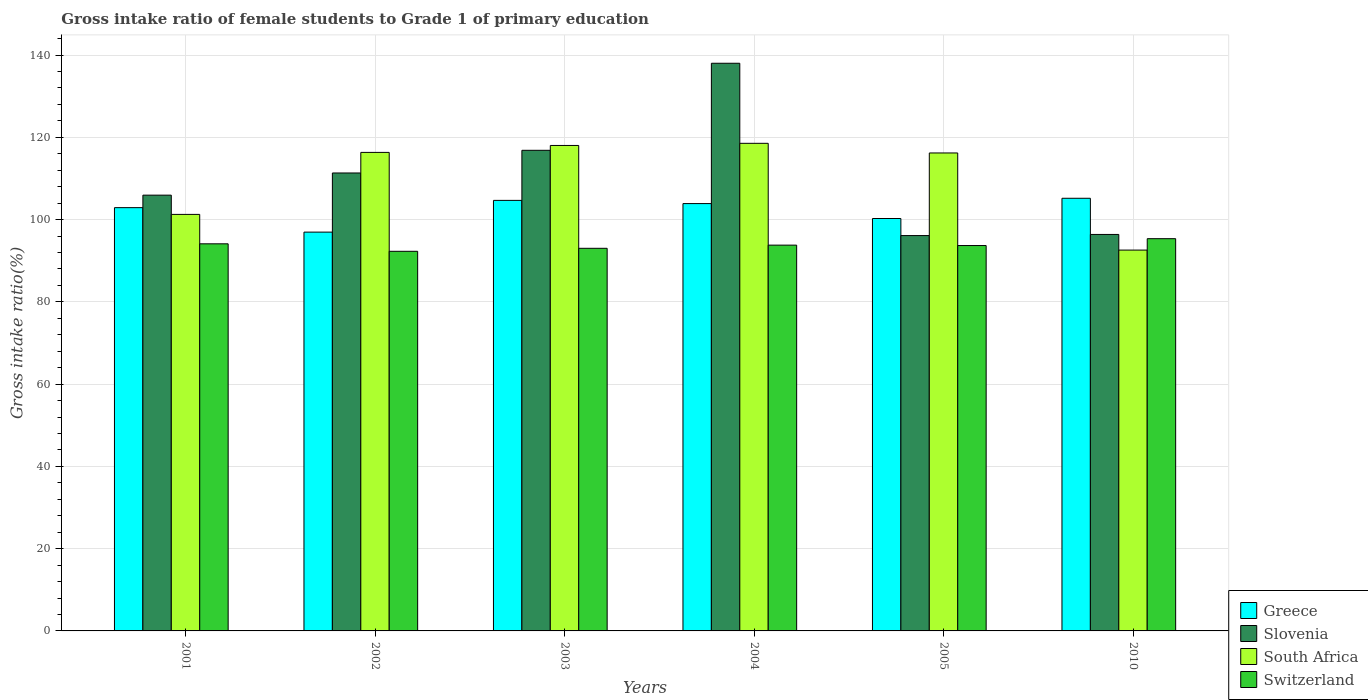Are the number of bars per tick equal to the number of legend labels?
Provide a succinct answer. Yes. How many bars are there on the 1st tick from the left?
Keep it short and to the point. 4. How many bars are there on the 1st tick from the right?
Offer a very short reply. 4. What is the label of the 6th group of bars from the left?
Your answer should be compact. 2010. What is the gross intake ratio in Greece in 2002?
Your answer should be very brief. 96.95. Across all years, what is the maximum gross intake ratio in Greece?
Your answer should be very brief. 105.18. Across all years, what is the minimum gross intake ratio in Slovenia?
Your answer should be compact. 96.11. In which year was the gross intake ratio in Switzerland minimum?
Your answer should be very brief. 2002. What is the total gross intake ratio in South Africa in the graph?
Your answer should be very brief. 662.92. What is the difference between the gross intake ratio in Switzerland in 2004 and that in 2010?
Keep it short and to the point. -1.57. What is the difference between the gross intake ratio in South Africa in 2003 and the gross intake ratio in Switzerland in 2004?
Provide a short and direct response. 24.23. What is the average gross intake ratio in Greece per year?
Ensure brevity in your answer.  102.31. In the year 2001, what is the difference between the gross intake ratio in South Africa and gross intake ratio in Switzerland?
Ensure brevity in your answer.  7.15. What is the ratio of the gross intake ratio in Slovenia in 2001 to that in 2003?
Your response must be concise. 0.91. Is the difference between the gross intake ratio in South Africa in 2004 and 2010 greater than the difference between the gross intake ratio in Switzerland in 2004 and 2010?
Provide a short and direct response. Yes. What is the difference between the highest and the second highest gross intake ratio in Slovenia?
Your answer should be very brief. 21.16. What is the difference between the highest and the lowest gross intake ratio in Greece?
Offer a terse response. 8.23. In how many years, is the gross intake ratio in Switzerland greater than the average gross intake ratio in Switzerland taken over all years?
Your response must be concise. 3. Is it the case that in every year, the sum of the gross intake ratio in South Africa and gross intake ratio in Greece is greater than the sum of gross intake ratio in Slovenia and gross intake ratio in Switzerland?
Your response must be concise. Yes. What does the 2nd bar from the left in 2001 represents?
Your response must be concise. Slovenia. What does the 2nd bar from the right in 2010 represents?
Your answer should be very brief. South Africa. Is it the case that in every year, the sum of the gross intake ratio in Switzerland and gross intake ratio in Slovenia is greater than the gross intake ratio in Greece?
Ensure brevity in your answer.  Yes. How many years are there in the graph?
Your answer should be compact. 6. What is the difference between two consecutive major ticks on the Y-axis?
Provide a short and direct response. 20. Are the values on the major ticks of Y-axis written in scientific E-notation?
Make the answer very short. No. Does the graph contain any zero values?
Provide a succinct answer. No. How are the legend labels stacked?
Provide a succinct answer. Vertical. What is the title of the graph?
Ensure brevity in your answer.  Gross intake ratio of female students to Grade 1 of primary education. What is the label or title of the X-axis?
Ensure brevity in your answer.  Years. What is the label or title of the Y-axis?
Offer a terse response. Gross intake ratio(%). What is the Gross intake ratio(%) of Greece in 2001?
Your answer should be very brief. 102.9. What is the Gross intake ratio(%) in Slovenia in 2001?
Keep it short and to the point. 105.94. What is the Gross intake ratio(%) of South Africa in 2001?
Provide a short and direct response. 101.26. What is the Gross intake ratio(%) of Switzerland in 2001?
Provide a short and direct response. 94.11. What is the Gross intake ratio(%) in Greece in 2002?
Provide a short and direct response. 96.95. What is the Gross intake ratio(%) of Slovenia in 2002?
Your answer should be very brief. 111.33. What is the Gross intake ratio(%) in South Africa in 2002?
Keep it short and to the point. 116.33. What is the Gross intake ratio(%) in Switzerland in 2002?
Keep it short and to the point. 92.29. What is the Gross intake ratio(%) of Greece in 2003?
Offer a terse response. 104.67. What is the Gross intake ratio(%) of Slovenia in 2003?
Your answer should be very brief. 116.84. What is the Gross intake ratio(%) of South Africa in 2003?
Give a very brief answer. 118.02. What is the Gross intake ratio(%) in Switzerland in 2003?
Your answer should be very brief. 93.01. What is the Gross intake ratio(%) of Greece in 2004?
Your answer should be very brief. 103.89. What is the Gross intake ratio(%) of Slovenia in 2004?
Give a very brief answer. 138. What is the Gross intake ratio(%) of South Africa in 2004?
Your response must be concise. 118.54. What is the Gross intake ratio(%) in Switzerland in 2004?
Offer a very short reply. 93.79. What is the Gross intake ratio(%) of Greece in 2005?
Your answer should be very brief. 100.26. What is the Gross intake ratio(%) of Slovenia in 2005?
Your response must be concise. 96.11. What is the Gross intake ratio(%) of South Africa in 2005?
Your answer should be compact. 116.2. What is the Gross intake ratio(%) in Switzerland in 2005?
Offer a very short reply. 93.69. What is the Gross intake ratio(%) of Greece in 2010?
Keep it short and to the point. 105.18. What is the Gross intake ratio(%) of Slovenia in 2010?
Offer a very short reply. 96.39. What is the Gross intake ratio(%) in South Africa in 2010?
Your answer should be very brief. 92.58. What is the Gross intake ratio(%) in Switzerland in 2010?
Your answer should be very brief. 95.36. Across all years, what is the maximum Gross intake ratio(%) in Greece?
Give a very brief answer. 105.18. Across all years, what is the maximum Gross intake ratio(%) of Slovenia?
Give a very brief answer. 138. Across all years, what is the maximum Gross intake ratio(%) in South Africa?
Give a very brief answer. 118.54. Across all years, what is the maximum Gross intake ratio(%) in Switzerland?
Your answer should be compact. 95.36. Across all years, what is the minimum Gross intake ratio(%) in Greece?
Make the answer very short. 96.95. Across all years, what is the minimum Gross intake ratio(%) of Slovenia?
Provide a short and direct response. 96.11. Across all years, what is the minimum Gross intake ratio(%) of South Africa?
Your response must be concise. 92.58. Across all years, what is the minimum Gross intake ratio(%) of Switzerland?
Keep it short and to the point. 92.29. What is the total Gross intake ratio(%) of Greece in the graph?
Make the answer very short. 613.84. What is the total Gross intake ratio(%) of Slovenia in the graph?
Make the answer very short. 664.6. What is the total Gross intake ratio(%) in South Africa in the graph?
Your answer should be very brief. 662.92. What is the total Gross intake ratio(%) of Switzerland in the graph?
Give a very brief answer. 562.24. What is the difference between the Gross intake ratio(%) of Greece in 2001 and that in 2002?
Offer a very short reply. 5.95. What is the difference between the Gross intake ratio(%) in Slovenia in 2001 and that in 2002?
Offer a terse response. -5.39. What is the difference between the Gross intake ratio(%) of South Africa in 2001 and that in 2002?
Your answer should be compact. -15.07. What is the difference between the Gross intake ratio(%) in Switzerland in 2001 and that in 2002?
Your response must be concise. 1.82. What is the difference between the Gross intake ratio(%) in Greece in 2001 and that in 2003?
Give a very brief answer. -1.77. What is the difference between the Gross intake ratio(%) in Slovenia in 2001 and that in 2003?
Ensure brevity in your answer.  -10.9. What is the difference between the Gross intake ratio(%) of South Africa in 2001 and that in 2003?
Make the answer very short. -16.76. What is the difference between the Gross intake ratio(%) in Switzerland in 2001 and that in 2003?
Offer a terse response. 1.09. What is the difference between the Gross intake ratio(%) of Greece in 2001 and that in 2004?
Provide a short and direct response. -0.99. What is the difference between the Gross intake ratio(%) in Slovenia in 2001 and that in 2004?
Offer a very short reply. -32.06. What is the difference between the Gross intake ratio(%) of South Africa in 2001 and that in 2004?
Provide a succinct answer. -17.28. What is the difference between the Gross intake ratio(%) in Switzerland in 2001 and that in 2004?
Provide a short and direct response. 0.32. What is the difference between the Gross intake ratio(%) of Greece in 2001 and that in 2005?
Keep it short and to the point. 2.64. What is the difference between the Gross intake ratio(%) in Slovenia in 2001 and that in 2005?
Offer a terse response. 9.83. What is the difference between the Gross intake ratio(%) in South Africa in 2001 and that in 2005?
Make the answer very short. -14.94. What is the difference between the Gross intake ratio(%) of Switzerland in 2001 and that in 2005?
Provide a short and direct response. 0.42. What is the difference between the Gross intake ratio(%) of Greece in 2001 and that in 2010?
Ensure brevity in your answer.  -2.28. What is the difference between the Gross intake ratio(%) of Slovenia in 2001 and that in 2010?
Offer a very short reply. 9.55. What is the difference between the Gross intake ratio(%) in South Africa in 2001 and that in 2010?
Provide a short and direct response. 8.68. What is the difference between the Gross intake ratio(%) in Switzerland in 2001 and that in 2010?
Provide a succinct answer. -1.25. What is the difference between the Gross intake ratio(%) of Greece in 2002 and that in 2003?
Offer a very short reply. -7.72. What is the difference between the Gross intake ratio(%) of Slovenia in 2002 and that in 2003?
Your answer should be very brief. -5.51. What is the difference between the Gross intake ratio(%) of South Africa in 2002 and that in 2003?
Provide a succinct answer. -1.69. What is the difference between the Gross intake ratio(%) in Switzerland in 2002 and that in 2003?
Keep it short and to the point. -0.73. What is the difference between the Gross intake ratio(%) in Greece in 2002 and that in 2004?
Keep it short and to the point. -6.94. What is the difference between the Gross intake ratio(%) of Slovenia in 2002 and that in 2004?
Provide a short and direct response. -26.67. What is the difference between the Gross intake ratio(%) of South Africa in 2002 and that in 2004?
Your answer should be compact. -2.21. What is the difference between the Gross intake ratio(%) in Switzerland in 2002 and that in 2004?
Keep it short and to the point. -1.5. What is the difference between the Gross intake ratio(%) of Greece in 2002 and that in 2005?
Offer a terse response. -3.31. What is the difference between the Gross intake ratio(%) of Slovenia in 2002 and that in 2005?
Provide a short and direct response. 15.22. What is the difference between the Gross intake ratio(%) in South Africa in 2002 and that in 2005?
Ensure brevity in your answer.  0.14. What is the difference between the Gross intake ratio(%) in Switzerland in 2002 and that in 2005?
Make the answer very short. -1.4. What is the difference between the Gross intake ratio(%) of Greece in 2002 and that in 2010?
Give a very brief answer. -8.23. What is the difference between the Gross intake ratio(%) of Slovenia in 2002 and that in 2010?
Keep it short and to the point. 14.94. What is the difference between the Gross intake ratio(%) of South Africa in 2002 and that in 2010?
Your response must be concise. 23.75. What is the difference between the Gross intake ratio(%) in Switzerland in 2002 and that in 2010?
Provide a succinct answer. -3.07. What is the difference between the Gross intake ratio(%) of Greece in 2003 and that in 2004?
Provide a short and direct response. 0.78. What is the difference between the Gross intake ratio(%) in Slovenia in 2003 and that in 2004?
Provide a succinct answer. -21.16. What is the difference between the Gross intake ratio(%) of South Africa in 2003 and that in 2004?
Your answer should be compact. -0.52. What is the difference between the Gross intake ratio(%) of Switzerland in 2003 and that in 2004?
Make the answer very short. -0.77. What is the difference between the Gross intake ratio(%) in Greece in 2003 and that in 2005?
Give a very brief answer. 4.41. What is the difference between the Gross intake ratio(%) in Slovenia in 2003 and that in 2005?
Give a very brief answer. 20.73. What is the difference between the Gross intake ratio(%) in South Africa in 2003 and that in 2005?
Your answer should be compact. 1.82. What is the difference between the Gross intake ratio(%) of Switzerland in 2003 and that in 2005?
Keep it short and to the point. -0.67. What is the difference between the Gross intake ratio(%) of Greece in 2003 and that in 2010?
Provide a succinct answer. -0.51. What is the difference between the Gross intake ratio(%) of Slovenia in 2003 and that in 2010?
Your answer should be very brief. 20.45. What is the difference between the Gross intake ratio(%) in South Africa in 2003 and that in 2010?
Keep it short and to the point. 25.44. What is the difference between the Gross intake ratio(%) in Switzerland in 2003 and that in 2010?
Your response must be concise. -2.34. What is the difference between the Gross intake ratio(%) of Greece in 2004 and that in 2005?
Your response must be concise. 3.62. What is the difference between the Gross intake ratio(%) in Slovenia in 2004 and that in 2005?
Provide a short and direct response. 41.89. What is the difference between the Gross intake ratio(%) in South Africa in 2004 and that in 2005?
Offer a terse response. 2.34. What is the difference between the Gross intake ratio(%) of Switzerland in 2004 and that in 2005?
Offer a terse response. 0.1. What is the difference between the Gross intake ratio(%) in Greece in 2004 and that in 2010?
Ensure brevity in your answer.  -1.29. What is the difference between the Gross intake ratio(%) in Slovenia in 2004 and that in 2010?
Keep it short and to the point. 41.61. What is the difference between the Gross intake ratio(%) in South Africa in 2004 and that in 2010?
Provide a succinct answer. 25.96. What is the difference between the Gross intake ratio(%) of Switzerland in 2004 and that in 2010?
Keep it short and to the point. -1.57. What is the difference between the Gross intake ratio(%) of Greece in 2005 and that in 2010?
Your answer should be compact. -4.92. What is the difference between the Gross intake ratio(%) of Slovenia in 2005 and that in 2010?
Your answer should be very brief. -0.28. What is the difference between the Gross intake ratio(%) of South Africa in 2005 and that in 2010?
Provide a succinct answer. 23.61. What is the difference between the Gross intake ratio(%) in Switzerland in 2005 and that in 2010?
Provide a short and direct response. -1.67. What is the difference between the Gross intake ratio(%) of Greece in 2001 and the Gross intake ratio(%) of Slovenia in 2002?
Provide a short and direct response. -8.43. What is the difference between the Gross intake ratio(%) in Greece in 2001 and the Gross intake ratio(%) in South Africa in 2002?
Offer a very short reply. -13.43. What is the difference between the Gross intake ratio(%) of Greece in 2001 and the Gross intake ratio(%) of Switzerland in 2002?
Give a very brief answer. 10.61. What is the difference between the Gross intake ratio(%) of Slovenia in 2001 and the Gross intake ratio(%) of South Africa in 2002?
Give a very brief answer. -10.39. What is the difference between the Gross intake ratio(%) of Slovenia in 2001 and the Gross intake ratio(%) of Switzerland in 2002?
Your answer should be compact. 13.65. What is the difference between the Gross intake ratio(%) in South Africa in 2001 and the Gross intake ratio(%) in Switzerland in 2002?
Give a very brief answer. 8.97. What is the difference between the Gross intake ratio(%) of Greece in 2001 and the Gross intake ratio(%) of Slovenia in 2003?
Give a very brief answer. -13.94. What is the difference between the Gross intake ratio(%) of Greece in 2001 and the Gross intake ratio(%) of South Africa in 2003?
Your answer should be very brief. -15.12. What is the difference between the Gross intake ratio(%) of Greece in 2001 and the Gross intake ratio(%) of Switzerland in 2003?
Provide a short and direct response. 9.88. What is the difference between the Gross intake ratio(%) in Slovenia in 2001 and the Gross intake ratio(%) in South Africa in 2003?
Offer a very short reply. -12.08. What is the difference between the Gross intake ratio(%) in Slovenia in 2001 and the Gross intake ratio(%) in Switzerland in 2003?
Ensure brevity in your answer.  12.92. What is the difference between the Gross intake ratio(%) of South Africa in 2001 and the Gross intake ratio(%) of Switzerland in 2003?
Provide a short and direct response. 8.24. What is the difference between the Gross intake ratio(%) of Greece in 2001 and the Gross intake ratio(%) of Slovenia in 2004?
Give a very brief answer. -35.1. What is the difference between the Gross intake ratio(%) of Greece in 2001 and the Gross intake ratio(%) of South Africa in 2004?
Keep it short and to the point. -15.64. What is the difference between the Gross intake ratio(%) in Greece in 2001 and the Gross intake ratio(%) in Switzerland in 2004?
Offer a very short reply. 9.11. What is the difference between the Gross intake ratio(%) in Slovenia in 2001 and the Gross intake ratio(%) in South Africa in 2004?
Make the answer very short. -12.6. What is the difference between the Gross intake ratio(%) in Slovenia in 2001 and the Gross intake ratio(%) in Switzerland in 2004?
Offer a very short reply. 12.15. What is the difference between the Gross intake ratio(%) in South Africa in 2001 and the Gross intake ratio(%) in Switzerland in 2004?
Offer a very short reply. 7.47. What is the difference between the Gross intake ratio(%) of Greece in 2001 and the Gross intake ratio(%) of Slovenia in 2005?
Ensure brevity in your answer.  6.79. What is the difference between the Gross intake ratio(%) of Greece in 2001 and the Gross intake ratio(%) of South Africa in 2005?
Give a very brief answer. -13.3. What is the difference between the Gross intake ratio(%) of Greece in 2001 and the Gross intake ratio(%) of Switzerland in 2005?
Offer a very short reply. 9.21. What is the difference between the Gross intake ratio(%) in Slovenia in 2001 and the Gross intake ratio(%) in South Africa in 2005?
Your response must be concise. -10.26. What is the difference between the Gross intake ratio(%) of Slovenia in 2001 and the Gross intake ratio(%) of Switzerland in 2005?
Ensure brevity in your answer.  12.25. What is the difference between the Gross intake ratio(%) of South Africa in 2001 and the Gross intake ratio(%) of Switzerland in 2005?
Provide a succinct answer. 7.57. What is the difference between the Gross intake ratio(%) of Greece in 2001 and the Gross intake ratio(%) of Slovenia in 2010?
Offer a terse response. 6.51. What is the difference between the Gross intake ratio(%) of Greece in 2001 and the Gross intake ratio(%) of South Africa in 2010?
Give a very brief answer. 10.32. What is the difference between the Gross intake ratio(%) of Greece in 2001 and the Gross intake ratio(%) of Switzerland in 2010?
Provide a succinct answer. 7.54. What is the difference between the Gross intake ratio(%) of Slovenia in 2001 and the Gross intake ratio(%) of South Africa in 2010?
Provide a short and direct response. 13.36. What is the difference between the Gross intake ratio(%) in Slovenia in 2001 and the Gross intake ratio(%) in Switzerland in 2010?
Keep it short and to the point. 10.58. What is the difference between the Gross intake ratio(%) in South Africa in 2001 and the Gross intake ratio(%) in Switzerland in 2010?
Offer a very short reply. 5.9. What is the difference between the Gross intake ratio(%) of Greece in 2002 and the Gross intake ratio(%) of Slovenia in 2003?
Offer a very short reply. -19.89. What is the difference between the Gross intake ratio(%) in Greece in 2002 and the Gross intake ratio(%) in South Africa in 2003?
Give a very brief answer. -21.07. What is the difference between the Gross intake ratio(%) in Greece in 2002 and the Gross intake ratio(%) in Switzerland in 2003?
Keep it short and to the point. 3.94. What is the difference between the Gross intake ratio(%) in Slovenia in 2002 and the Gross intake ratio(%) in South Africa in 2003?
Offer a terse response. -6.69. What is the difference between the Gross intake ratio(%) in Slovenia in 2002 and the Gross intake ratio(%) in Switzerland in 2003?
Provide a short and direct response. 18.31. What is the difference between the Gross intake ratio(%) of South Africa in 2002 and the Gross intake ratio(%) of Switzerland in 2003?
Your answer should be very brief. 23.32. What is the difference between the Gross intake ratio(%) of Greece in 2002 and the Gross intake ratio(%) of Slovenia in 2004?
Offer a terse response. -41.05. What is the difference between the Gross intake ratio(%) of Greece in 2002 and the Gross intake ratio(%) of South Africa in 2004?
Provide a succinct answer. -21.59. What is the difference between the Gross intake ratio(%) of Greece in 2002 and the Gross intake ratio(%) of Switzerland in 2004?
Give a very brief answer. 3.16. What is the difference between the Gross intake ratio(%) of Slovenia in 2002 and the Gross intake ratio(%) of South Africa in 2004?
Your answer should be very brief. -7.21. What is the difference between the Gross intake ratio(%) in Slovenia in 2002 and the Gross intake ratio(%) in Switzerland in 2004?
Your answer should be compact. 17.54. What is the difference between the Gross intake ratio(%) of South Africa in 2002 and the Gross intake ratio(%) of Switzerland in 2004?
Offer a terse response. 22.54. What is the difference between the Gross intake ratio(%) in Greece in 2002 and the Gross intake ratio(%) in Slovenia in 2005?
Provide a succinct answer. 0.84. What is the difference between the Gross intake ratio(%) of Greece in 2002 and the Gross intake ratio(%) of South Africa in 2005?
Your response must be concise. -19.25. What is the difference between the Gross intake ratio(%) in Greece in 2002 and the Gross intake ratio(%) in Switzerland in 2005?
Offer a very short reply. 3.26. What is the difference between the Gross intake ratio(%) in Slovenia in 2002 and the Gross intake ratio(%) in South Africa in 2005?
Ensure brevity in your answer.  -4.87. What is the difference between the Gross intake ratio(%) in Slovenia in 2002 and the Gross intake ratio(%) in Switzerland in 2005?
Ensure brevity in your answer.  17.64. What is the difference between the Gross intake ratio(%) of South Africa in 2002 and the Gross intake ratio(%) of Switzerland in 2005?
Offer a terse response. 22.64. What is the difference between the Gross intake ratio(%) of Greece in 2002 and the Gross intake ratio(%) of Slovenia in 2010?
Make the answer very short. 0.56. What is the difference between the Gross intake ratio(%) in Greece in 2002 and the Gross intake ratio(%) in South Africa in 2010?
Provide a succinct answer. 4.37. What is the difference between the Gross intake ratio(%) in Greece in 2002 and the Gross intake ratio(%) in Switzerland in 2010?
Provide a short and direct response. 1.59. What is the difference between the Gross intake ratio(%) of Slovenia in 2002 and the Gross intake ratio(%) of South Africa in 2010?
Your answer should be very brief. 18.75. What is the difference between the Gross intake ratio(%) in Slovenia in 2002 and the Gross intake ratio(%) in Switzerland in 2010?
Offer a terse response. 15.97. What is the difference between the Gross intake ratio(%) of South Africa in 2002 and the Gross intake ratio(%) of Switzerland in 2010?
Provide a short and direct response. 20.98. What is the difference between the Gross intake ratio(%) of Greece in 2003 and the Gross intake ratio(%) of Slovenia in 2004?
Provide a short and direct response. -33.33. What is the difference between the Gross intake ratio(%) of Greece in 2003 and the Gross intake ratio(%) of South Africa in 2004?
Provide a succinct answer. -13.87. What is the difference between the Gross intake ratio(%) of Greece in 2003 and the Gross intake ratio(%) of Switzerland in 2004?
Ensure brevity in your answer.  10.88. What is the difference between the Gross intake ratio(%) in Slovenia in 2003 and the Gross intake ratio(%) in South Africa in 2004?
Ensure brevity in your answer.  -1.7. What is the difference between the Gross intake ratio(%) in Slovenia in 2003 and the Gross intake ratio(%) in Switzerland in 2004?
Make the answer very short. 23.05. What is the difference between the Gross intake ratio(%) in South Africa in 2003 and the Gross intake ratio(%) in Switzerland in 2004?
Make the answer very short. 24.23. What is the difference between the Gross intake ratio(%) of Greece in 2003 and the Gross intake ratio(%) of Slovenia in 2005?
Your answer should be very brief. 8.56. What is the difference between the Gross intake ratio(%) in Greece in 2003 and the Gross intake ratio(%) in South Africa in 2005?
Keep it short and to the point. -11.53. What is the difference between the Gross intake ratio(%) in Greece in 2003 and the Gross intake ratio(%) in Switzerland in 2005?
Offer a terse response. 10.98. What is the difference between the Gross intake ratio(%) in Slovenia in 2003 and the Gross intake ratio(%) in South Africa in 2005?
Provide a short and direct response. 0.64. What is the difference between the Gross intake ratio(%) of Slovenia in 2003 and the Gross intake ratio(%) of Switzerland in 2005?
Keep it short and to the point. 23.15. What is the difference between the Gross intake ratio(%) in South Africa in 2003 and the Gross intake ratio(%) in Switzerland in 2005?
Offer a terse response. 24.33. What is the difference between the Gross intake ratio(%) of Greece in 2003 and the Gross intake ratio(%) of Slovenia in 2010?
Offer a very short reply. 8.28. What is the difference between the Gross intake ratio(%) in Greece in 2003 and the Gross intake ratio(%) in South Africa in 2010?
Offer a very short reply. 12.09. What is the difference between the Gross intake ratio(%) in Greece in 2003 and the Gross intake ratio(%) in Switzerland in 2010?
Keep it short and to the point. 9.31. What is the difference between the Gross intake ratio(%) in Slovenia in 2003 and the Gross intake ratio(%) in South Africa in 2010?
Keep it short and to the point. 24.26. What is the difference between the Gross intake ratio(%) of Slovenia in 2003 and the Gross intake ratio(%) of Switzerland in 2010?
Your answer should be compact. 21.48. What is the difference between the Gross intake ratio(%) of South Africa in 2003 and the Gross intake ratio(%) of Switzerland in 2010?
Ensure brevity in your answer.  22.66. What is the difference between the Gross intake ratio(%) in Greece in 2004 and the Gross intake ratio(%) in Slovenia in 2005?
Keep it short and to the point. 7.78. What is the difference between the Gross intake ratio(%) of Greece in 2004 and the Gross intake ratio(%) of South Africa in 2005?
Make the answer very short. -12.31. What is the difference between the Gross intake ratio(%) of Greece in 2004 and the Gross intake ratio(%) of Switzerland in 2005?
Your answer should be very brief. 10.2. What is the difference between the Gross intake ratio(%) in Slovenia in 2004 and the Gross intake ratio(%) in South Africa in 2005?
Your response must be concise. 21.81. What is the difference between the Gross intake ratio(%) in Slovenia in 2004 and the Gross intake ratio(%) in Switzerland in 2005?
Make the answer very short. 44.31. What is the difference between the Gross intake ratio(%) of South Africa in 2004 and the Gross intake ratio(%) of Switzerland in 2005?
Offer a terse response. 24.85. What is the difference between the Gross intake ratio(%) in Greece in 2004 and the Gross intake ratio(%) in Slovenia in 2010?
Keep it short and to the point. 7.5. What is the difference between the Gross intake ratio(%) of Greece in 2004 and the Gross intake ratio(%) of South Africa in 2010?
Ensure brevity in your answer.  11.3. What is the difference between the Gross intake ratio(%) in Greece in 2004 and the Gross intake ratio(%) in Switzerland in 2010?
Offer a very short reply. 8.53. What is the difference between the Gross intake ratio(%) of Slovenia in 2004 and the Gross intake ratio(%) of South Africa in 2010?
Ensure brevity in your answer.  45.42. What is the difference between the Gross intake ratio(%) of Slovenia in 2004 and the Gross intake ratio(%) of Switzerland in 2010?
Offer a terse response. 42.65. What is the difference between the Gross intake ratio(%) in South Africa in 2004 and the Gross intake ratio(%) in Switzerland in 2010?
Provide a succinct answer. 23.18. What is the difference between the Gross intake ratio(%) in Greece in 2005 and the Gross intake ratio(%) in Slovenia in 2010?
Offer a very short reply. 3.87. What is the difference between the Gross intake ratio(%) of Greece in 2005 and the Gross intake ratio(%) of South Africa in 2010?
Keep it short and to the point. 7.68. What is the difference between the Gross intake ratio(%) in Greece in 2005 and the Gross intake ratio(%) in Switzerland in 2010?
Your response must be concise. 4.91. What is the difference between the Gross intake ratio(%) of Slovenia in 2005 and the Gross intake ratio(%) of South Africa in 2010?
Offer a terse response. 3.53. What is the difference between the Gross intake ratio(%) in Slovenia in 2005 and the Gross intake ratio(%) in Switzerland in 2010?
Offer a terse response. 0.75. What is the difference between the Gross intake ratio(%) in South Africa in 2005 and the Gross intake ratio(%) in Switzerland in 2010?
Offer a terse response. 20.84. What is the average Gross intake ratio(%) in Greece per year?
Make the answer very short. 102.31. What is the average Gross intake ratio(%) of Slovenia per year?
Offer a very short reply. 110.77. What is the average Gross intake ratio(%) in South Africa per year?
Provide a short and direct response. 110.49. What is the average Gross intake ratio(%) of Switzerland per year?
Offer a terse response. 93.71. In the year 2001, what is the difference between the Gross intake ratio(%) of Greece and Gross intake ratio(%) of Slovenia?
Keep it short and to the point. -3.04. In the year 2001, what is the difference between the Gross intake ratio(%) in Greece and Gross intake ratio(%) in South Africa?
Keep it short and to the point. 1.64. In the year 2001, what is the difference between the Gross intake ratio(%) in Greece and Gross intake ratio(%) in Switzerland?
Provide a succinct answer. 8.79. In the year 2001, what is the difference between the Gross intake ratio(%) in Slovenia and Gross intake ratio(%) in South Africa?
Make the answer very short. 4.68. In the year 2001, what is the difference between the Gross intake ratio(%) of Slovenia and Gross intake ratio(%) of Switzerland?
Make the answer very short. 11.83. In the year 2001, what is the difference between the Gross intake ratio(%) of South Africa and Gross intake ratio(%) of Switzerland?
Your answer should be very brief. 7.15. In the year 2002, what is the difference between the Gross intake ratio(%) of Greece and Gross intake ratio(%) of Slovenia?
Keep it short and to the point. -14.38. In the year 2002, what is the difference between the Gross intake ratio(%) in Greece and Gross intake ratio(%) in South Africa?
Ensure brevity in your answer.  -19.38. In the year 2002, what is the difference between the Gross intake ratio(%) in Greece and Gross intake ratio(%) in Switzerland?
Offer a very short reply. 4.66. In the year 2002, what is the difference between the Gross intake ratio(%) of Slovenia and Gross intake ratio(%) of South Africa?
Your answer should be compact. -5. In the year 2002, what is the difference between the Gross intake ratio(%) of Slovenia and Gross intake ratio(%) of Switzerland?
Give a very brief answer. 19.04. In the year 2002, what is the difference between the Gross intake ratio(%) of South Africa and Gross intake ratio(%) of Switzerland?
Give a very brief answer. 24.04. In the year 2003, what is the difference between the Gross intake ratio(%) in Greece and Gross intake ratio(%) in Slovenia?
Provide a succinct answer. -12.17. In the year 2003, what is the difference between the Gross intake ratio(%) in Greece and Gross intake ratio(%) in South Africa?
Ensure brevity in your answer.  -13.35. In the year 2003, what is the difference between the Gross intake ratio(%) of Greece and Gross intake ratio(%) of Switzerland?
Give a very brief answer. 11.65. In the year 2003, what is the difference between the Gross intake ratio(%) of Slovenia and Gross intake ratio(%) of South Africa?
Provide a succinct answer. -1.18. In the year 2003, what is the difference between the Gross intake ratio(%) in Slovenia and Gross intake ratio(%) in Switzerland?
Give a very brief answer. 23.82. In the year 2003, what is the difference between the Gross intake ratio(%) of South Africa and Gross intake ratio(%) of Switzerland?
Make the answer very short. 25. In the year 2004, what is the difference between the Gross intake ratio(%) in Greece and Gross intake ratio(%) in Slovenia?
Offer a very short reply. -34.12. In the year 2004, what is the difference between the Gross intake ratio(%) in Greece and Gross intake ratio(%) in South Africa?
Provide a succinct answer. -14.65. In the year 2004, what is the difference between the Gross intake ratio(%) of Greece and Gross intake ratio(%) of Switzerland?
Ensure brevity in your answer.  10.1. In the year 2004, what is the difference between the Gross intake ratio(%) of Slovenia and Gross intake ratio(%) of South Africa?
Ensure brevity in your answer.  19.46. In the year 2004, what is the difference between the Gross intake ratio(%) of Slovenia and Gross intake ratio(%) of Switzerland?
Give a very brief answer. 44.21. In the year 2004, what is the difference between the Gross intake ratio(%) in South Africa and Gross intake ratio(%) in Switzerland?
Keep it short and to the point. 24.75. In the year 2005, what is the difference between the Gross intake ratio(%) in Greece and Gross intake ratio(%) in Slovenia?
Your answer should be compact. 4.15. In the year 2005, what is the difference between the Gross intake ratio(%) in Greece and Gross intake ratio(%) in South Africa?
Offer a very short reply. -15.93. In the year 2005, what is the difference between the Gross intake ratio(%) of Greece and Gross intake ratio(%) of Switzerland?
Keep it short and to the point. 6.57. In the year 2005, what is the difference between the Gross intake ratio(%) in Slovenia and Gross intake ratio(%) in South Africa?
Your answer should be very brief. -20.09. In the year 2005, what is the difference between the Gross intake ratio(%) of Slovenia and Gross intake ratio(%) of Switzerland?
Offer a terse response. 2.42. In the year 2005, what is the difference between the Gross intake ratio(%) of South Africa and Gross intake ratio(%) of Switzerland?
Make the answer very short. 22.51. In the year 2010, what is the difference between the Gross intake ratio(%) in Greece and Gross intake ratio(%) in Slovenia?
Your answer should be very brief. 8.79. In the year 2010, what is the difference between the Gross intake ratio(%) of Greece and Gross intake ratio(%) of South Africa?
Offer a terse response. 12.6. In the year 2010, what is the difference between the Gross intake ratio(%) in Greece and Gross intake ratio(%) in Switzerland?
Your answer should be compact. 9.82. In the year 2010, what is the difference between the Gross intake ratio(%) in Slovenia and Gross intake ratio(%) in South Africa?
Make the answer very short. 3.81. In the year 2010, what is the difference between the Gross intake ratio(%) of Slovenia and Gross intake ratio(%) of Switzerland?
Your answer should be compact. 1.03. In the year 2010, what is the difference between the Gross intake ratio(%) of South Africa and Gross intake ratio(%) of Switzerland?
Your answer should be compact. -2.77. What is the ratio of the Gross intake ratio(%) of Greece in 2001 to that in 2002?
Your response must be concise. 1.06. What is the ratio of the Gross intake ratio(%) in Slovenia in 2001 to that in 2002?
Offer a very short reply. 0.95. What is the ratio of the Gross intake ratio(%) in South Africa in 2001 to that in 2002?
Your answer should be very brief. 0.87. What is the ratio of the Gross intake ratio(%) of Switzerland in 2001 to that in 2002?
Keep it short and to the point. 1.02. What is the ratio of the Gross intake ratio(%) in Greece in 2001 to that in 2003?
Provide a succinct answer. 0.98. What is the ratio of the Gross intake ratio(%) of Slovenia in 2001 to that in 2003?
Your answer should be compact. 0.91. What is the ratio of the Gross intake ratio(%) of South Africa in 2001 to that in 2003?
Offer a terse response. 0.86. What is the ratio of the Gross intake ratio(%) of Switzerland in 2001 to that in 2003?
Make the answer very short. 1.01. What is the ratio of the Gross intake ratio(%) of Greece in 2001 to that in 2004?
Your answer should be very brief. 0.99. What is the ratio of the Gross intake ratio(%) of Slovenia in 2001 to that in 2004?
Offer a very short reply. 0.77. What is the ratio of the Gross intake ratio(%) of South Africa in 2001 to that in 2004?
Provide a succinct answer. 0.85. What is the ratio of the Gross intake ratio(%) in Switzerland in 2001 to that in 2004?
Make the answer very short. 1. What is the ratio of the Gross intake ratio(%) in Greece in 2001 to that in 2005?
Provide a short and direct response. 1.03. What is the ratio of the Gross intake ratio(%) of Slovenia in 2001 to that in 2005?
Keep it short and to the point. 1.1. What is the ratio of the Gross intake ratio(%) in South Africa in 2001 to that in 2005?
Give a very brief answer. 0.87. What is the ratio of the Gross intake ratio(%) of Switzerland in 2001 to that in 2005?
Provide a short and direct response. 1. What is the ratio of the Gross intake ratio(%) of Greece in 2001 to that in 2010?
Your response must be concise. 0.98. What is the ratio of the Gross intake ratio(%) of Slovenia in 2001 to that in 2010?
Give a very brief answer. 1.1. What is the ratio of the Gross intake ratio(%) in South Africa in 2001 to that in 2010?
Offer a terse response. 1.09. What is the ratio of the Gross intake ratio(%) in Switzerland in 2001 to that in 2010?
Your response must be concise. 0.99. What is the ratio of the Gross intake ratio(%) in Greece in 2002 to that in 2003?
Make the answer very short. 0.93. What is the ratio of the Gross intake ratio(%) of Slovenia in 2002 to that in 2003?
Ensure brevity in your answer.  0.95. What is the ratio of the Gross intake ratio(%) in South Africa in 2002 to that in 2003?
Keep it short and to the point. 0.99. What is the ratio of the Gross intake ratio(%) in Greece in 2002 to that in 2004?
Provide a succinct answer. 0.93. What is the ratio of the Gross intake ratio(%) in Slovenia in 2002 to that in 2004?
Your answer should be very brief. 0.81. What is the ratio of the Gross intake ratio(%) of South Africa in 2002 to that in 2004?
Provide a short and direct response. 0.98. What is the ratio of the Gross intake ratio(%) in Switzerland in 2002 to that in 2004?
Give a very brief answer. 0.98. What is the ratio of the Gross intake ratio(%) of Greece in 2002 to that in 2005?
Ensure brevity in your answer.  0.97. What is the ratio of the Gross intake ratio(%) of Slovenia in 2002 to that in 2005?
Offer a terse response. 1.16. What is the ratio of the Gross intake ratio(%) in Switzerland in 2002 to that in 2005?
Provide a short and direct response. 0.99. What is the ratio of the Gross intake ratio(%) in Greece in 2002 to that in 2010?
Offer a very short reply. 0.92. What is the ratio of the Gross intake ratio(%) of Slovenia in 2002 to that in 2010?
Your response must be concise. 1.16. What is the ratio of the Gross intake ratio(%) of South Africa in 2002 to that in 2010?
Your response must be concise. 1.26. What is the ratio of the Gross intake ratio(%) in Switzerland in 2002 to that in 2010?
Make the answer very short. 0.97. What is the ratio of the Gross intake ratio(%) of Greece in 2003 to that in 2004?
Your answer should be compact. 1.01. What is the ratio of the Gross intake ratio(%) in Slovenia in 2003 to that in 2004?
Your answer should be very brief. 0.85. What is the ratio of the Gross intake ratio(%) in Greece in 2003 to that in 2005?
Your answer should be compact. 1.04. What is the ratio of the Gross intake ratio(%) in Slovenia in 2003 to that in 2005?
Your response must be concise. 1.22. What is the ratio of the Gross intake ratio(%) in South Africa in 2003 to that in 2005?
Offer a very short reply. 1.02. What is the ratio of the Gross intake ratio(%) of Greece in 2003 to that in 2010?
Give a very brief answer. 1. What is the ratio of the Gross intake ratio(%) in Slovenia in 2003 to that in 2010?
Offer a very short reply. 1.21. What is the ratio of the Gross intake ratio(%) of South Africa in 2003 to that in 2010?
Your response must be concise. 1.27. What is the ratio of the Gross intake ratio(%) of Switzerland in 2003 to that in 2010?
Offer a terse response. 0.98. What is the ratio of the Gross intake ratio(%) in Greece in 2004 to that in 2005?
Give a very brief answer. 1.04. What is the ratio of the Gross intake ratio(%) in Slovenia in 2004 to that in 2005?
Your answer should be very brief. 1.44. What is the ratio of the Gross intake ratio(%) of South Africa in 2004 to that in 2005?
Your answer should be very brief. 1.02. What is the ratio of the Gross intake ratio(%) of Switzerland in 2004 to that in 2005?
Offer a terse response. 1. What is the ratio of the Gross intake ratio(%) in Greece in 2004 to that in 2010?
Your response must be concise. 0.99. What is the ratio of the Gross intake ratio(%) in Slovenia in 2004 to that in 2010?
Your answer should be very brief. 1.43. What is the ratio of the Gross intake ratio(%) in South Africa in 2004 to that in 2010?
Provide a short and direct response. 1.28. What is the ratio of the Gross intake ratio(%) of Switzerland in 2004 to that in 2010?
Provide a succinct answer. 0.98. What is the ratio of the Gross intake ratio(%) of Greece in 2005 to that in 2010?
Offer a terse response. 0.95. What is the ratio of the Gross intake ratio(%) of South Africa in 2005 to that in 2010?
Offer a terse response. 1.26. What is the ratio of the Gross intake ratio(%) of Switzerland in 2005 to that in 2010?
Keep it short and to the point. 0.98. What is the difference between the highest and the second highest Gross intake ratio(%) in Greece?
Keep it short and to the point. 0.51. What is the difference between the highest and the second highest Gross intake ratio(%) in Slovenia?
Your response must be concise. 21.16. What is the difference between the highest and the second highest Gross intake ratio(%) in South Africa?
Your response must be concise. 0.52. What is the difference between the highest and the second highest Gross intake ratio(%) in Switzerland?
Keep it short and to the point. 1.25. What is the difference between the highest and the lowest Gross intake ratio(%) in Greece?
Ensure brevity in your answer.  8.23. What is the difference between the highest and the lowest Gross intake ratio(%) in Slovenia?
Give a very brief answer. 41.89. What is the difference between the highest and the lowest Gross intake ratio(%) of South Africa?
Offer a terse response. 25.96. What is the difference between the highest and the lowest Gross intake ratio(%) of Switzerland?
Provide a succinct answer. 3.07. 